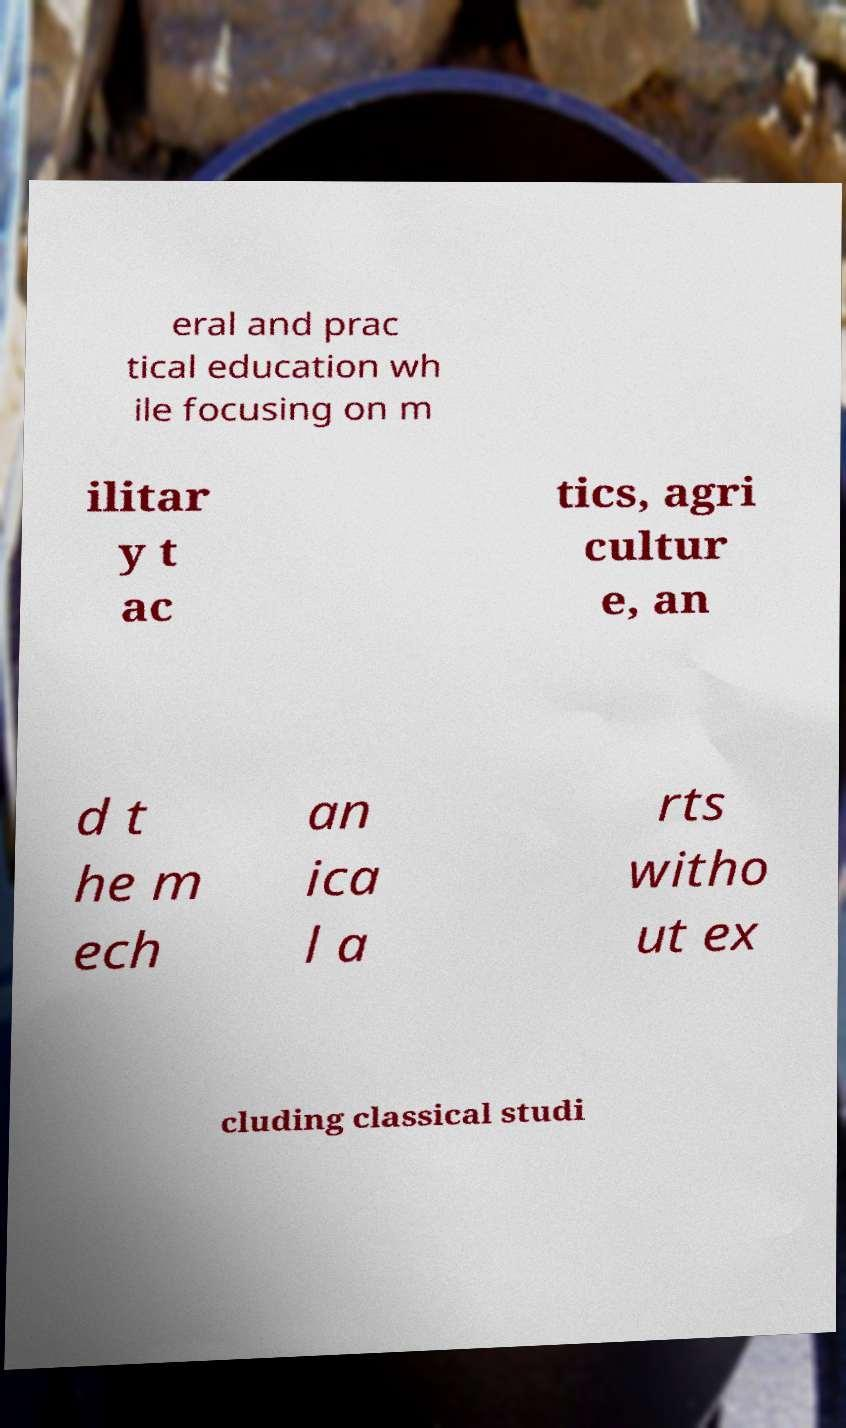For documentation purposes, I need the text within this image transcribed. Could you provide that? eral and prac tical education wh ile focusing on m ilitar y t ac tics, agri cultur e, an d t he m ech an ica l a rts witho ut ex cluding classical studi 